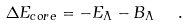Convert formula to latex. <formula><loc_0><loc_0><loc_500><loc_500>\Delta E _ { c o r e } = - E _ { \Lambda } - B _ { \Lambda } \ \ .</formula> 